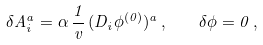<formula> <loc_0><loc_0><loc_500><loc_500>\delta A ^ { a } _ { i } = \alpha \, \frac { 1 } { v } \, ( D _ { i } \phi ^ { ( 0 ) } ) ^ { a } \, , \quad \delta \phi = 0 \, ,</formula> 